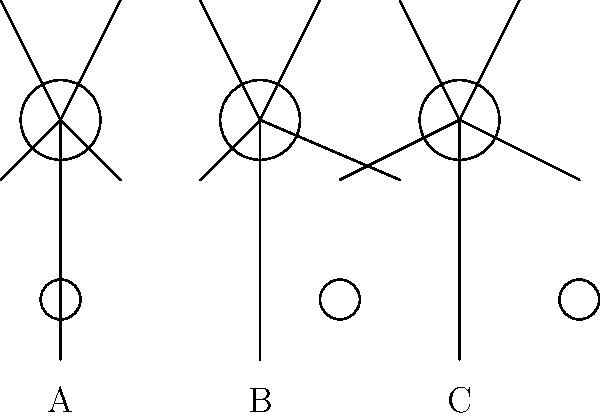In the stick figure animation above, three different dribbling techniques are shown: A (low dribble), B (crossover), and C (wide dribble). Which technique is most effective for maintaining ball control while maximizing the player's ability to change direction quickly? To answer this question, we need to consider the biomechanics of each dribbling technique:

1. Low dribble (A):
   - Keeps the ball close to the ground
   - Reduces the time the ball is in the air
   - Provides better control but limits mobility

2. Crossover (B):
   - Involves moving the ball from one hand to the other
   - Creates deception and can throw off defenders
   - Allows for quick changes in direction
   - Requires precise timing and hand-eye coordination

3. Wide dribble (C):
   - Keeps the ball farther from the body
   - Creates space between the player and defender
   - Allows for longer strides but may sacrifice some control

Considering the need for ball control and the ability to change direction quickly:

- The low dribble (A) offers great control but limits the player's ability to make rapid direction changes due to the constrained body position.
- The wide dribble (C) allows for longer strides and creates space, but the ball is more exposed and harder to control during quick movements.
- The crossover (B) provides a balance between control and agility. It keeps the ball relatively close to the body while allowing for rapid direction changes. The transfer of the ball from one hand to the other facilitates quick pivots and direction shifts.

Therefore, the crossover technique (B) is most effective for maintaining ball control while maximizing the player's ability to change direction quickly.
Answer: Crossover (B) 